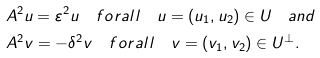Convert formula to latex. <formula><loc_0><loc_0><loc_500><loc_500>& A ^ { 2 } u = \varepsilon ^ { 2 } u \quad f o r a l l \quad u = ( u _ { 1 } , u _ { 2 } ) \in U \quad a n d \\ & A ^ { 2 } v = - \delta ^ { 2 } v \quad f o r a l l \quad v = ( v _ { 1 } , v _ { 2 } ) \in U ^ { \bot } .</formula> 